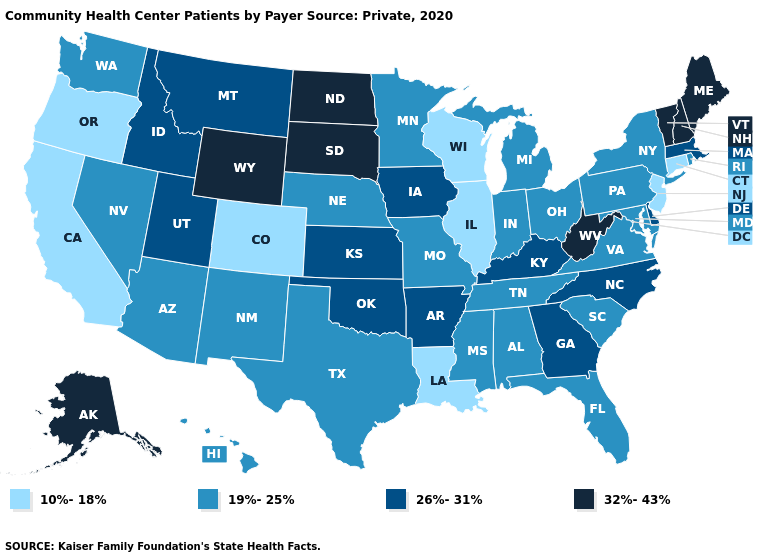Among the states that border Connecticut , does Massachusetts have the highest value?
Short answer required. Yes. What is the value of Mississippi?
Quick response, please. 19%-25%. What is the highest value in states that border Alabama?
Short answer required. 26%-31%. Name the states that have a value in the range 32%-43%?
Answer briefly. Alaska, Maine, New Hampshire, North Dakota, South Dakota, Vermont, West Virginia, Wyoming. Does Louisiana have the same value as California?
Write a very short answer. Yes. Does Wisconsin have a lower value than Illinois?
Be succinct. No. Does Wisconsin have the lowest value in the USA?
Answer briefly. Yes. What is the highest value in states that border Montana?
Keep it brief. 32%-43%. What is the value of New York?
Give a very brief answer. 19%-25%. What is the lowest value in the MidWest?
Concise answer only. 10%-18%. Name the states that have a value in the range 26%-31%?
Give a very brief answer. Arkansas, Delaware, Georgia, Idaho, Iowa, Kansas, Kentucky, Massachusetts, Montana, North Carolina, Oklahoma, Utah. Which states have the lowest value in the USA?
Quick response, please. California, Colorado, Connecticut, Illinois, Louisiana, New Jersey, Oregon, Wisconsin. Among the states that border Michigan , does Wisconsin have the highest value?
Short answer required. No. What is the value of Montana?
Give a very brief answer. 26%-31%. What is the value of Louisiana?
Keep it brief. 10%-18%. 